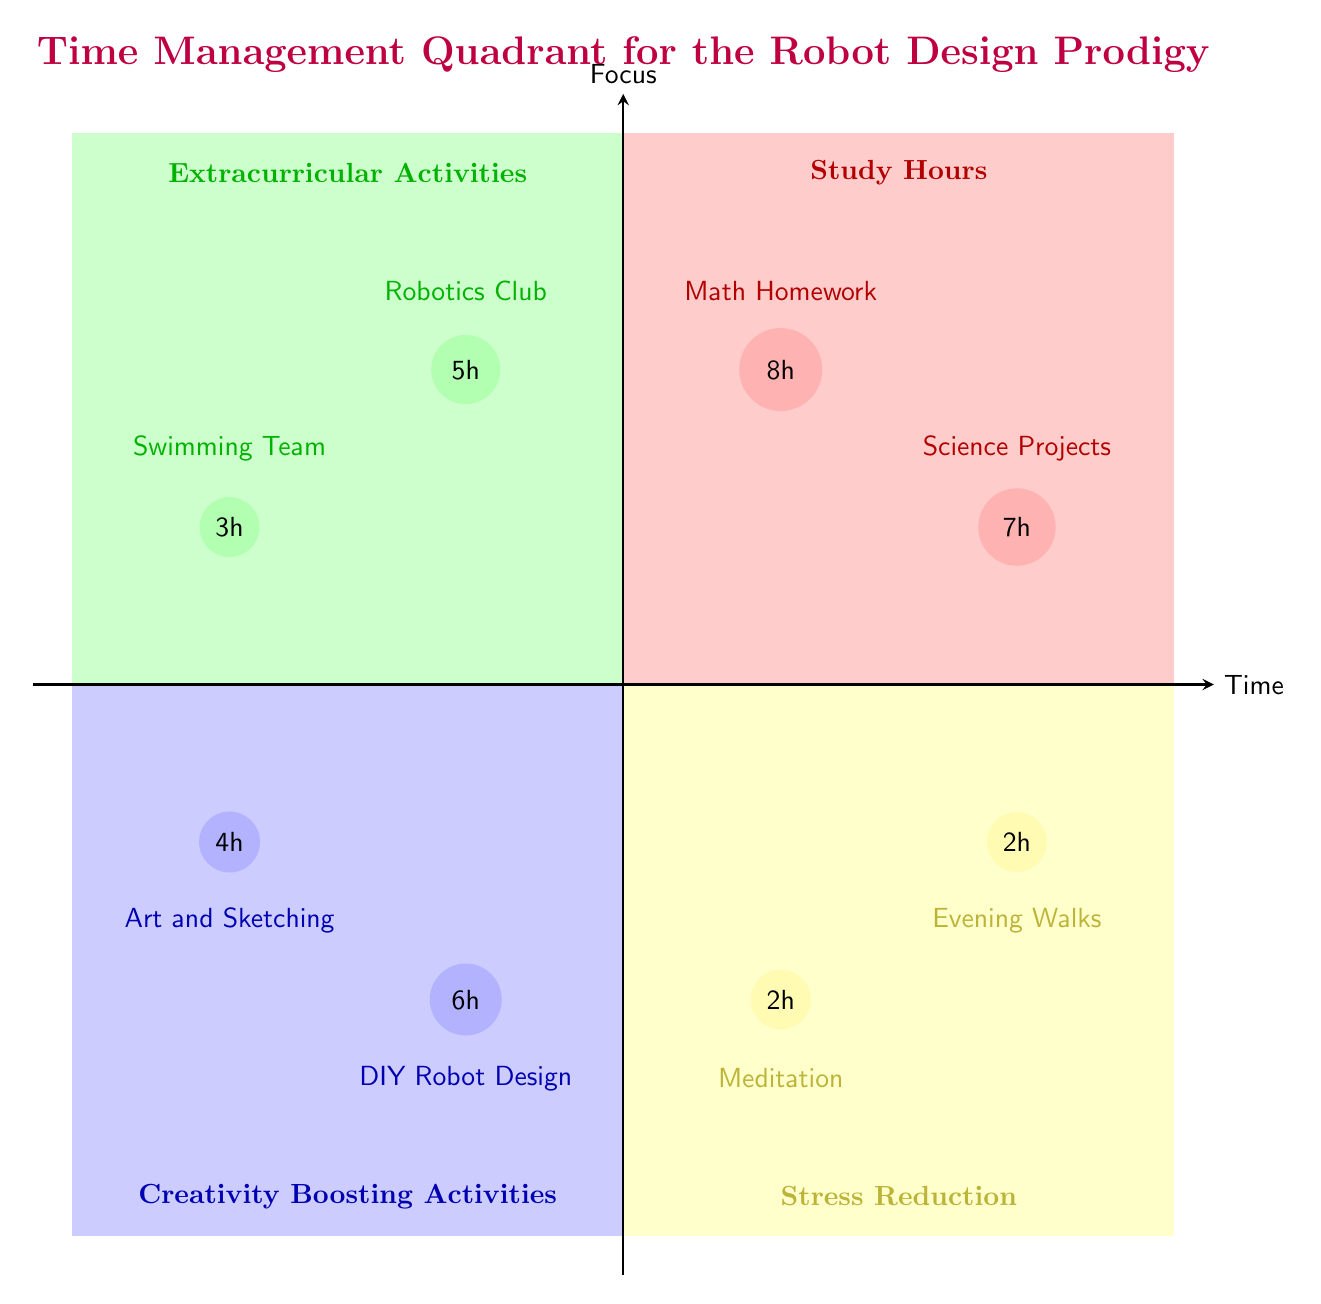What are the total study hours represented in Q1? In Q1, there are two elements: Math Homework (8 hours) and Science Projects (7 hours). To find the total study hours, we add these two values: 8 + 7 = 15.
Answer: 15 How many hours are allocated to the Robotics Club? The Robotics Club is listed in Q2 as having 5 hours allocated to it. This is directly visible in the quadrant.
Answer: 5 Which activity in Q3 has more allocated hours: DIY Robot Design or Art and Sketching? In Q3, DIY Robot Design has 6 hours allocated, while Art and Sketching has 4 hours. Since 6 is greater than 4, DIY Robot Design has more hours allocated.
Answer: DIY Robot Design What is the total amount of time spent on stress reduction activities in Q4? The stress reduction activities listed in Q4 are Meditation (2 hours) and Evening Walks (2 hours). To find the total, we add these values: 2 + 2 = 4.
Answer: 4 Which quadrant has the least amount of total allocated hours across its activities? To determine this, we sum allocated hours in each quadrant: Q1 has 15 hours, Q2 has 8 hours (5+3), Q3 has 10 hours (6+4), and Q4 has 4 hours. Q4 has the least total at 4 hours.
Answer: Q4 Which quadrant focuses primarily on academic work? The quadrant that focuses on academic work is Q1, as it consists of study hours allocated to Math Homework and Science Projects.
Answer: Q1 How many different activities are represented in Q2? Q2 lists two activities: Robotics Club and Swimming Team. Counting these gives us a total of 2 activities.
Answer: 2 What is the relationship between Creativity Boosting Activities and Stress Reduction in terms of hours allocated? Creativity Boosting Activities (Q3) has 10 hours allocated (6+4), while Stress Reduction (Q4) has 4 hours. Thus, Creativity Boosting Activities has significantly more hours allocated compared to Stress Reduction.
Answer: Creativity Boosting Activities has more hours Which activity is more time-intensive: Math Homework or DIY Robot Design? The time allocated to Math Homework is 8 hours, whereas DIY Robot Design has 6 hours. Comparing these values, Math Homework is more time-intensive.
Answer: Math Homework 